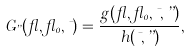<formula> <loc_0><loc_0><loc_500><loc_500>G _ { \varepsilon } ( \gamma , \gamma _ { 0 } , \mu ) = \frac { g ( \gamma , \gamma _ { 0 } , \mu , \varepsilon ) } { h ( \mu , \varepsilon ) } ,</formula> 